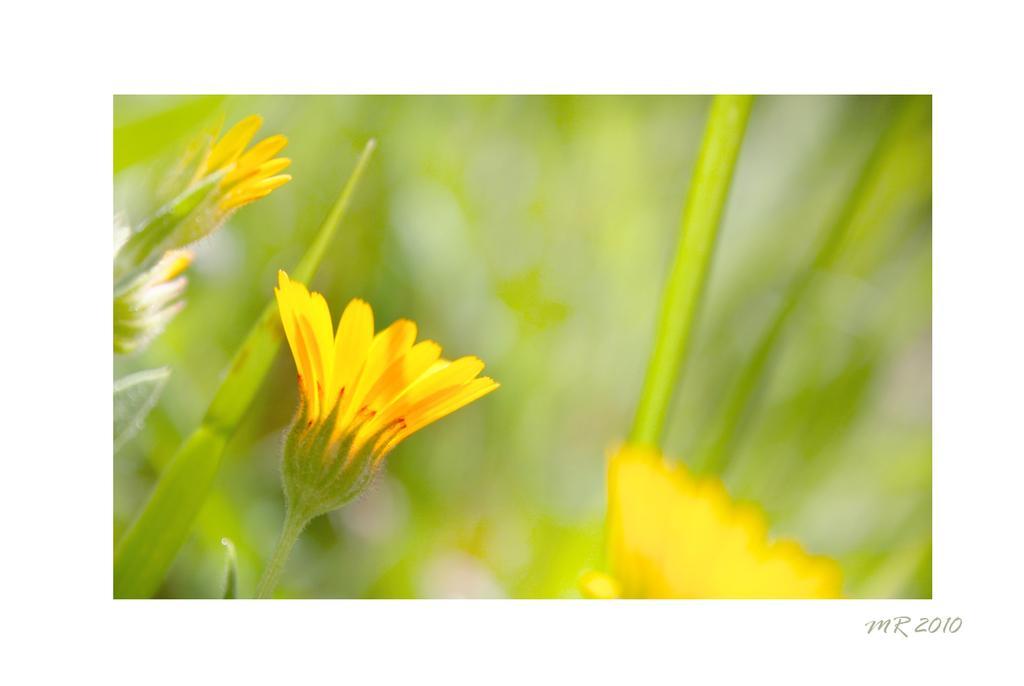Describe this image in one or two sentences. In the image I can see a poster in which there are some yellow color flowers to the plants. 